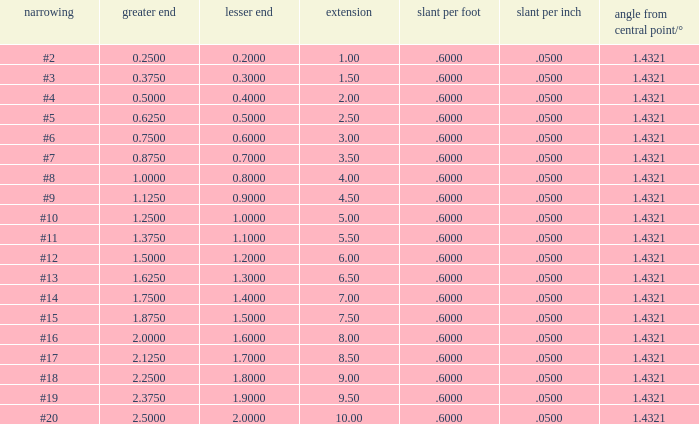Which Angle from center/° has a Taper/ft smaller than 0.6000000000000001? 19.0. 